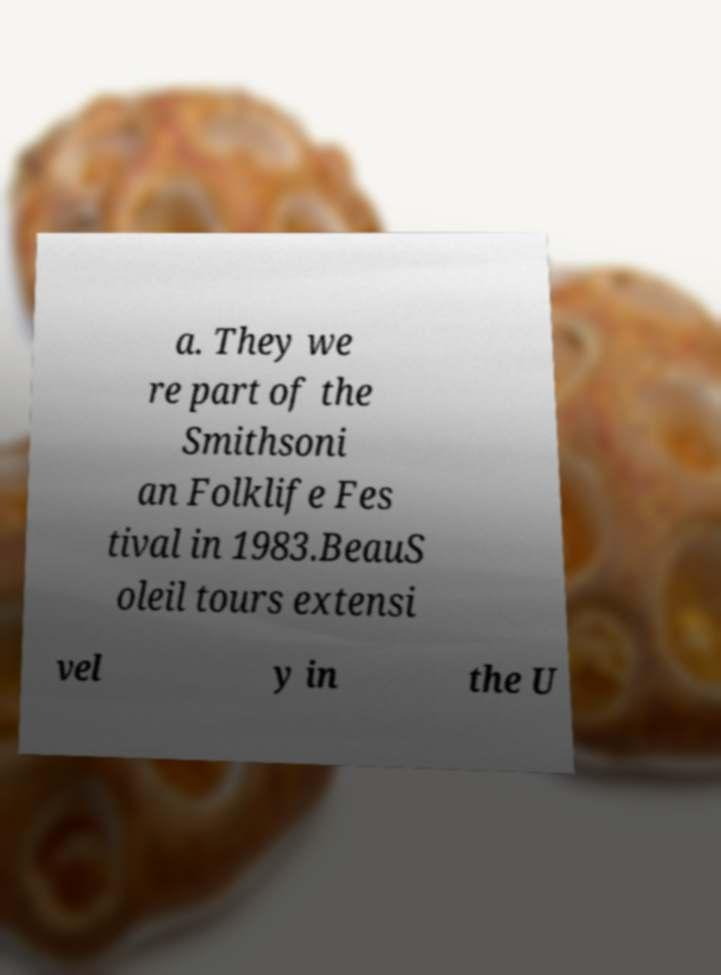Please identify and transcribe the text found in this image. a. They we re part of the Smithsoni an Folklife Fes tival in 1983.BeauS oleil tours extensi vel y in the U 